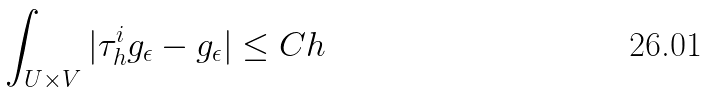<formula> <loc_0><loc_0><loc_500><loc_500>\int _ { U \times V } | \tau ^ { i } _ { h } g _ { \epsilon } - g _ { \epsilon } | \leq C h</formula> 